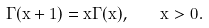Convert formula to latex. <formula><loc_0><loc_0><loc_500><loc_500>\Gamma ( x + 1 ) = x \Gamma ( x ) , \quad x > 0 .</formula> 